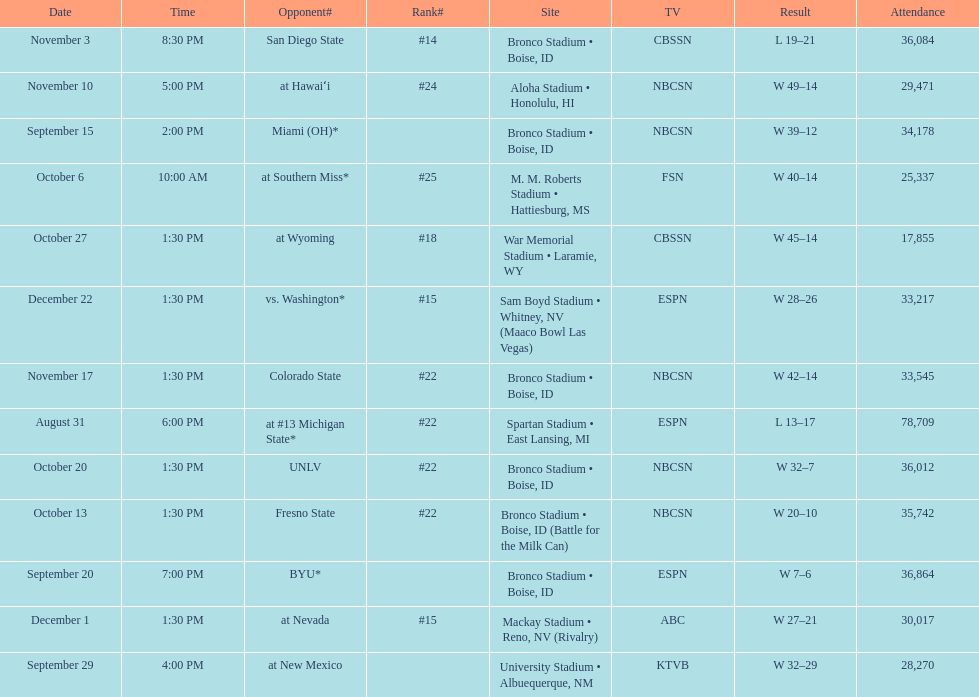Number of points scored by miami (oh) against the broncos. 12. 